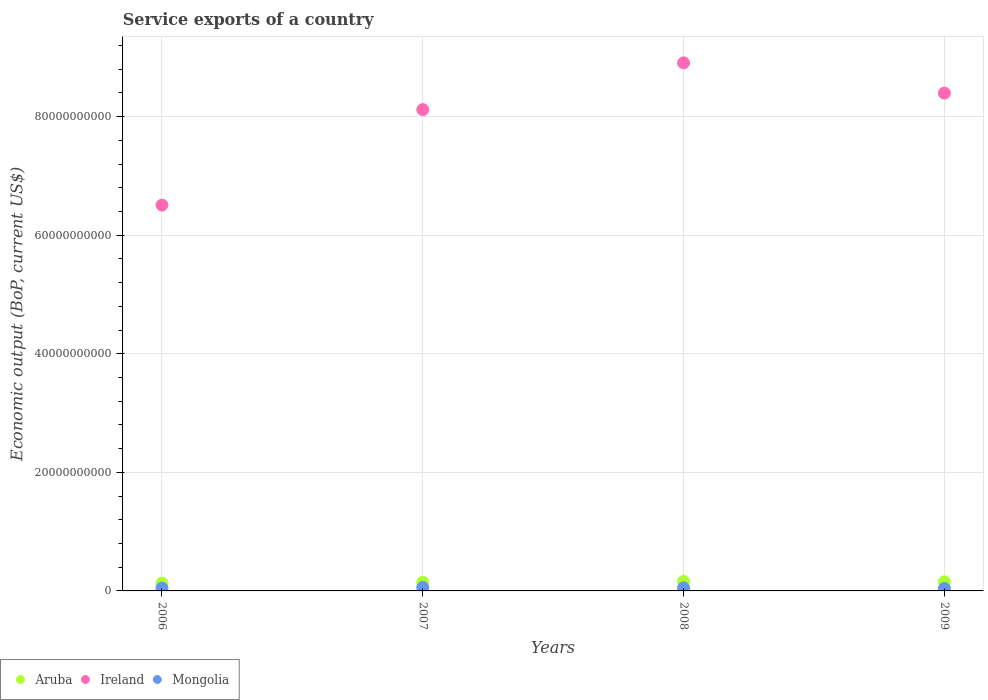How many different coloured dotlines are there?
Your answer should be very brief. 3. What is the service exports in Aruba in 2006?
Provide a succinct answer. 1.31e+09. Across all years, what is the maximum service exports in Aruba?
Your response must be concise. 1.60e+09. Across all years, what is the minimum service exports in Mongolia?
Your answer should be very brief. 4.17e+08. In which year was the service exports in Mongolia maximum?
Make the answer very short. 2007. What is the total service exports in Aruba in the graph?
Offer a very short reply. 5.92e+09. What is the difference between the service exports in Ireland in 2008 and that in 2009?
Make the answer very short. 5.10e+09. What is the difference between the service exports in Aruba in 2006 and the service exports in Mongolia in 2008?
Provide a short and direct response. 7.89e+08. What is the average service exports in Ireland per year?
Offer a terse response. 7.98e+1. In the year 2007, what is the difference between the service exports in Aruba and service exports in Mongolia?
Make the answer very short. 8.89e+08. What is the ratio of the service exports in Aruba in 2008 to that in 2009?
Your response must be concise. 1.04. Is the service exports in Ireland in 2006 less than that in 2007?
Make the answer very short. Yes. Is the difference between the service exports in Aruba in 2007 and 2008 greater than the difference between the service exports in Mongolia in 2007 and 2008?
Keep it short and to the point. No. What is the difference between the highest and the second highest service exports in Mongolia?
Give a very brief answer. 6.19e+07. What is the difference between the highest and the lowest service exports in Mongolia?
Your answer should be compact. 1.65e+08. In how many years, is the service exports in Mongolia greater than the average service exports in Mongolia taken over all years?
Your answer should be compact. 2. Is it the case that in every year, the sum of the service exports in Ireland and service exports in Mongolia  is greater than the service exports in Aruba?
Provide a succinct answer. Yes. Does the service exports in Mongolia monotonically increase over the years?
Offer a very short reply. No. Is the service exports in Aruba strictly greater than the service exports in Mongolia over the years?
Keep it short and to the point. Yes. How many dotlines are there?
Your response must be concise. 3. How many years are there in the graph?
Give a very brief answer. 4. What is the difference between two consecutive major ticks on the Y-axis?
Ensure brevity in your answer.  2.00e+1. Are the values on the major ticks of Y-axis written in scientific E-notation?
Make the answer very short. No. Does the graph contain grids?
Make the answer very short. Yes. Where does the legend appear in the graph?
Ensure brevity in your answer.  Bottom left. How are the legend labels stacked?
Your answer should be very brief. Horizontal. What is the title of the graph?
Provide a succinct answer. Service exports of a country. Does "Sub-Saharan Africa (all income levels)" appear as one of the legend labels in the graph?
Your response must be concise. No. What is the label or title of the X-axis?
Ensure brevity in your answer.  Years. What is the label or title of the Y-axis?
Make the answer very short. Economic output (BoP, current US$). What is the Economic output (BoP, current US$) of Aruba in 2006?
Your answer should be very brief. 1.31e+09. What is the Economic output (BoP, current US$) of Ireland in 2006?
Offer a terse response. 6.51e+1. What is the Economic output (BoP, current US$) of Mongolia in 2006?
Make the answer very short. 4.86e+08. What is the Economic output (BoP, current US$) of Aruba in 2007?
Offer a very short reply. 1.47e+09. What is the Economic output (BoP, current US$) in Ireland in 2007?
Offer a terse response. 8.12e+1. What is the Economic output (BoP, current US$) of Mongolia in 2007?
Provide a succinct answer. 5.82e+08. What is the Economic output (BoP, current US$) of Aruba in 2008?
Ensure brevity in your answer.  1.60e+09. What is the Economic output (BoP, current US$) of Ireland in 2008?
Provide a succinct answer. 8.91e+1. What is the Economic output (BoP, current US$) in Mongolia in 2008?
Keep it short and to the point. 5.20e+08. What is the Economic output (BoP, current US$) of Aruba in 2009?
Offer a terse response. 1.54e+09. What is the Economic output (BoP, current US$) of Ireland in 2009?
Provide a succinct answer. 8.40e+1. What is the Economic output (BoP, current US$) of Mongolia in 2009?
Offer a very short reply. 4.17e+08. Across all years, what is the maximum Economic output (BoP, current US$) of Aruba?
Your answer should be compact. 1.60e+09. Across all years, what is the maximum Economic output (BoP, current US$) of Ireland?
Your answer should be compact. 8.91e+1. Across all years, what is the maximum Economic output (BoP, current US$) in Mongolia?
Keep it short and to the point. 5.82e+08. Across all years, what is the minimum Economic output (BoP, current US$) of Aruba?
Your response must be concise. 1.31e+09. Across all years, what is the minimum Economic output (BoP, current US$) in Ireland?
Provide a short and direct response. 6.51e+1. Across all years, what is the minimum Economic output (BoP, current US$) of Mongolia?
Your answer should be compact. 4.17e+08. What is the total Economic output (BoP, current US$) in Aruba in the graph?
Your answer should be very brief. 5.92e+09. What is the total Economic output (BoP, current US$) in Ireland in the graph?
Provide a succinct answer. 3.19e+11. What is the total Economic output (BoP, current US$) in Mongolia in the graph?
Offer a very short reply. 2.00e+09. What is the difference between the Economic output (BoP, current US$) in Aruba in 2006 and that in 2007?
Offer a very short reply. -1.62e+08. What is the difference between the Economic output (BoP, current US$) in Ireland in 2006 and that in 2007?
Your answer should be compact. -1.61e+1. What is the difference between the Economic output (BoP, current US$) of Mongolia in 2006 and that in 2007?
Provide a short and direct response. -9.61e+07. What is the difference between the Economic output (BoP, current US$) of Aruba in 2006 and that in 2008?
Your response must be concise. -2.94e+08. What is the difference between the Economic output (BoP, current US$) in Ireland in 2006 and that in 2008?
Your answer should be compact. -2.40e+1. What is the difference between the Economic output (BoP, current US$) in Mongolia in 2006 and that in 2008?
Ensure brevity in your answer.  -3.42e+07. What is the difference between the Economic output (BoP, current US$) of Aruba in 2006 and that in 2009?
Make the answer very short. -2.29e+08. What is the difference between the Economic output (BoP, current US$) of Ireland in 2006 and that in 2009?
Give a very brief answer. -1.89e+1. What is the difference between the Economic output (BoP, current US$) in Mongolia in 2006 and that in 2009?
Make the answer very short. 6.86e+07. What is the difference between the Economic output (BoP, current US$) in Aruba in 2007 and that in 2008?
Your response must be concise. -1.32e+08. What is the difference between the Economic output (BoP, current US$) of Ireland in 2007 and that in 2008?
Provide a short and direct response. -7.89e+09. What is the difference between the Economic output (BoP, current US$) of Mongolia in 2007 and that in 2008?
Your response must be concise. 6.19e+07. What is the difference between the Economic output (BoP, current US$) of Aruba in 2007 and that in 2009?
Ensure brevity in your answer.  -6.70e+07. What is the difference between the Economic output (BoP, current US$) in Ireland in 2007 and that in 2009?
Provide a short and direct response. -2.79e+09. What is the difference between the Economic output (BoP, current US$) of Mongolia in 2007 and that in 2009?
Your answer should be very brief. 1.65e+08. What is the difference between the Economic output (BoP, current US$) in Aruba in 2008 and that in 2009?
Your response must be concise. 6.48e+07. What is the difference between the Economic output (BoP, current US$) of Ireland in 2008 and that in 2009?
Make the answer very short. 5.10e+09. What is the difference between the Economic output (BoP, current US$) of Mongolia in 2008 and that in 2009?
Give a very brief answer. 1.03e+08. What is the difference between the Economic output (BoP, current US$) of Aruba in 2006 and the Economic output (BoP, current US$) of Ireland in 2007?
Your answer should be compact. -7.99e+1. What is the difference between the Economic output (BoP, current US$) of Aruba in 2006 and the Economic output (BoP, current US$) of Mongolia in 2007?
Keep it short and to the point. 7.27e+08. What is the difference between the Economic output (BoP, current US$) of Ireland in 2006 and the Economic output (BoP, current US$) of Mongolia in 2007?
Offer a very short reply. 6.45e+1. What is the difference between the Economic output (BoP, current US$) of Aruba in 2006 and the Economic output (BoP, current US$) of Ireland in 2008?
Your response must be concise. -8.78e+1. What is the difference between the Economic output (BoP, current US$) of Aruba in 2006 and the Economic output (BoP, current US$) of Mongolia in 2008?
Your response must be concise. 7.89e+08. What is the difference between the Economic output (BoP, current US$) of Ireland in 2006 and the Economic output (BoP, current US$) of Mongolia in 2008?
Provide a short and direct response. 6.45e+1. What is the difference between the Economic output (BoP, current US$) of Aruba in 2006 and the Economic output (BoP, current US$) of Ireland in 2009?
Your answer should be compact. -8.27e+1. What is the difference between the Economic output (BoP, current US$) in Aruba in 2006 and the Economic output (BoP, current US$) in Mongolia in 2009?
Provide a succinct answer. 8.92e+08. What is the difference between the Economic output (BoP, current US$) in Ireland in 2006 and the Economic output (BoP, current US$) in Mongolia in 2009?
Give a very brief answer. 6.47e+1. What is the difference between the Economic output (BoP, current US$) in Aruba in 2007 and the Economic output (BoP, current US$) in Ireland in 2008?
Keep it short and to the point. -8.76e+1. What is the difference between the Economic output (BoP, current US$) in Aruba in 2007 and the Economic output (BoP, current US$) in Mongolia in 2008?
Your answer should be very brief. 9.51e+08. What is the difference between the Economic output (BoP, current US$) in Ireland in 2007 and the Economic output (BoP, current US$) in Mongolia in 2008?
Ensure brevity in your answer.  8.07e+1. What is the difference between the Economic output (BoP, current US$) of Aruba in 2007 and the Economic output (BoP, current US$) of Ireland in 2009?
Provide a succinct answer. -8.25e+1. What is the difference between the Economic output (BoP, current US$) in Aruba in 2007 and the Economic output (BoP, current US$) in Mongolia in 2009?
Offer a terse response. 1.05e+09. What is the difference between the Economic output (BoP, current US$) in Ireland in 2007 and the Economic output (BoP, current US$) in Mongolia in 2009?
Make the answer very short. 8.08e+1. What is the difference between the Economic output (BoP, current US$) in Aruba in 2008 and the Economic output (BoP, current US$) in Ireland in 2009?
Your answer should be compact. -8.24e+1. What is the difference between the Economic output (BoP, current US$) in Aruba in 2008 and the Economic output (BoP, current US$) in Mongolia in 2009?
Keep it short and to the point. 1.19e+09. What is the difference between the Economic output (BoP, current US$) in Ireland in 2008 and the Economic output (BoP, current US$) in Mongolia in 2009?
Give a very brief answer. 8.86e+1. What is the average Economic output (BoP, current US$) in Aruba per year?
Provide a succinct answer. 1.48e+09. What is the average Economic output (BoP, current US$) of Ireland per year?
Your answer should be very brief. 7.98e+1. What is the average Economic output (BoP, current US$) of Mongolia per year?
Your answer should be compact. 5.01e+08. In the year 2006, what is the difference between the Economic output (BoP, current US$) of Aruba and Economic output (BoP, current US$) of Ireland?
Offer a very short reply. -6.38e+1. In the year 2006, what is the difference between the Economic output (BoP, current US$) of Aruba and Economic output (BoP, current US$) of Mongolia?
Keep it short and to the point. 8.23e+08. In the year 2006, what is the difference between the Economic output (BoP, current US$) of Ireland and Economic output (BoP, current US$) of Mongolia?
Offer a terse response. 6.46e+1. In the year 2007, what is the difference between the Economic output (BoP, current US$) of Aruba and Economic output (BoP, current US$) of Ireland?
Offer a terse response. -7.97e+1. In the year 2007, what is the difference between the Economic output (BoP, current US$) of Aruba and Economic output (BoP, current US$) of Mongolia?
Your answer should be compact. 8.89e+08. In the year 2007, what is the difference between the Economic output (BoP, current US$) in Ireland and Economic output (BoP, current US$) in Mongolia?
Your response must be concise. 8.06e+1. In the year 2008, what is the difference between the Economic output (BoP, current US$) in Aruba and Economic output (BoP, current US$) in Ireland?
Offer a very short reply. -8.75e+1. In the year 2008, what is the difference between the Economic output (BoP, current US$) of Aruba and Economic output (BoP, current US$) of Mongolia?
Keep it short and to the point. 1.08e+09. In the year 2008, what is the difference between the Economic output (BoP, current US$) of Ireland and Economic output (BoP, current US$) of Mongolia?
Your answer should be compact. 8.85e+1. In the year 2009, what is the difference between the Economic output (BoP, current US$) in Aruba and Economic output (BoP, current US$) in Ireland?
Your answer should be very brief. -8.24e+1. In the year 2009, what is the difference between the Economic output (BoP, current US$) in Aruba and Economic output (BoP, current US$) in Mongolia?
Offer a very short reply. 1.12e+09. In the year 2009, what is the difference between the Economic output (BoP, current US$) of Ireland and Economic output (BoP, current US$) of Mongolia?
Offer a terse response. 8.35e+1. What is the ratio of the Economic output (BoP, current US$) in Aruba in 2006 to that in 2007?
Your answer should be very brief. 0.89. What is the ratio of the Economic output (BoP, current US$) of Ireland in 2006 to that in 2007?
Ensure brevity in your answer.  0.8. What is the ratio of the Economic output (BoP, current US$) in Mongolia in 2006 to that in 2007?
Your answer should be very brief. 0.83. What is the ratio of the Economic output (BoP, current US$) of Aruba in 2006 to that in 2008?
Make the answer very short. 0.82. What is the ratio of the Economic output (BoP, current US$) of Ireland in 2006 to that in 2008?
Ensure brevity in your answer.  0.73. What is the ratio of the Economic output (BoP, current US$) of Mongolia in 2006 to that in 2008?
Keep it short and to the point. 0.93. What is the ratio of the Economic output (BoP, current US$) of Aruba in 2006 to that in 2009?
Give a very brief answer. 0.85. What is the ratio of the Economic output (BoP, current US$) in Ireland in 2006 to that in 2009?
Your answer should be compact. 0.78. What is the ratio of the Economic output (BoP, current US$) of Mongolia in 2006 to that in 2009?
Provide a succinct answer. 1.16. What is the ratio of the Economic output (BoP, current US$) of Aruba in 2007 to that in 2008?
Ensure brevity in your answer.  0.92. What is the ratio of the Economic output (BoP, current US$) in Ireland in 2007 to that in 2008?
Your answer should be compact. 0.91. What is the ratio of the Economic output (BoP, current US$) in Mongolia in 2007 to that in 2008?
Make the answer very short. 1.12. What is the ratio of the Economic output (BoP, current US$) of Aruba in 2007 to that in 2009?
Offer a very short reply. 0.96. What is the ratio of the Economic output (BoP, current US$) in Ireland in 2007 to that in 2009?
Give a very brief answer. 0.97. What is the ratio of the Economic output (BoP, current US$) in Mongolia in 2007 to that in 2009?
Your answer should be very brief. 1.39. What is the ratio of the Economic output (BoP, current US$) in Aruba in 2008 to that in 2009?
Your answer should be very brief. 1.04. What is the ratio of the Economic output (BoP, current US$) in Ireland in 2008 to that in 2009?
Give a very brief answer. 1.06. What is the ratio of the Economic output (BoP, current US$) of Mongolia in 2008 to that in 2009?
Offer a terse response. 1.25. What is the difference between the highest and the second highest Economic output (BoP, current US$) of Aruba?
Your answer should be compact. 6.48e+07. What is the difference between the highest and the second highest Economic output (BoP, current US$) of Ireland?
Provide a short and direct response. 5.10e+09. What is the difference between the highest and the second highest Economic output (BoP, current US$) of Mongolia?
Keep it short and to the point. 6.19e+07. What is the difference between the highest and the lowest Economic output (BoP, current US$) of Aruba?
Your response must be concise. 2.94e+08. What is the difference between the highest and the lowest Economic output (BoP, current US$) of Ireland?
Keep it short and to the point. 2.40e+1. What is the difference between the highest and the lowest Economic output (BoP, current US$) of Mongolia?
Give a very brief answer. 1.65e+08. 